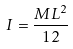Convert formula to latex. <formula><loc_0><loc_0><loc_500><loc_500>I = \frac { M L ^ { 2 } } { 1 2 }</formula> 